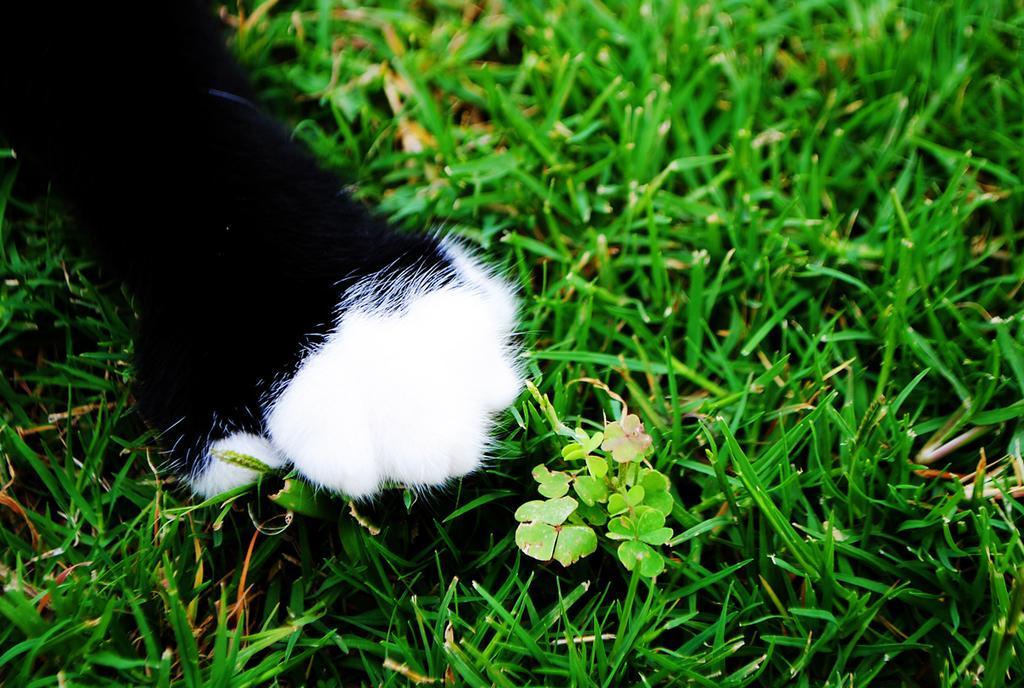Can you describe this image briefly? In this image, there is an animal hand on the grass. 